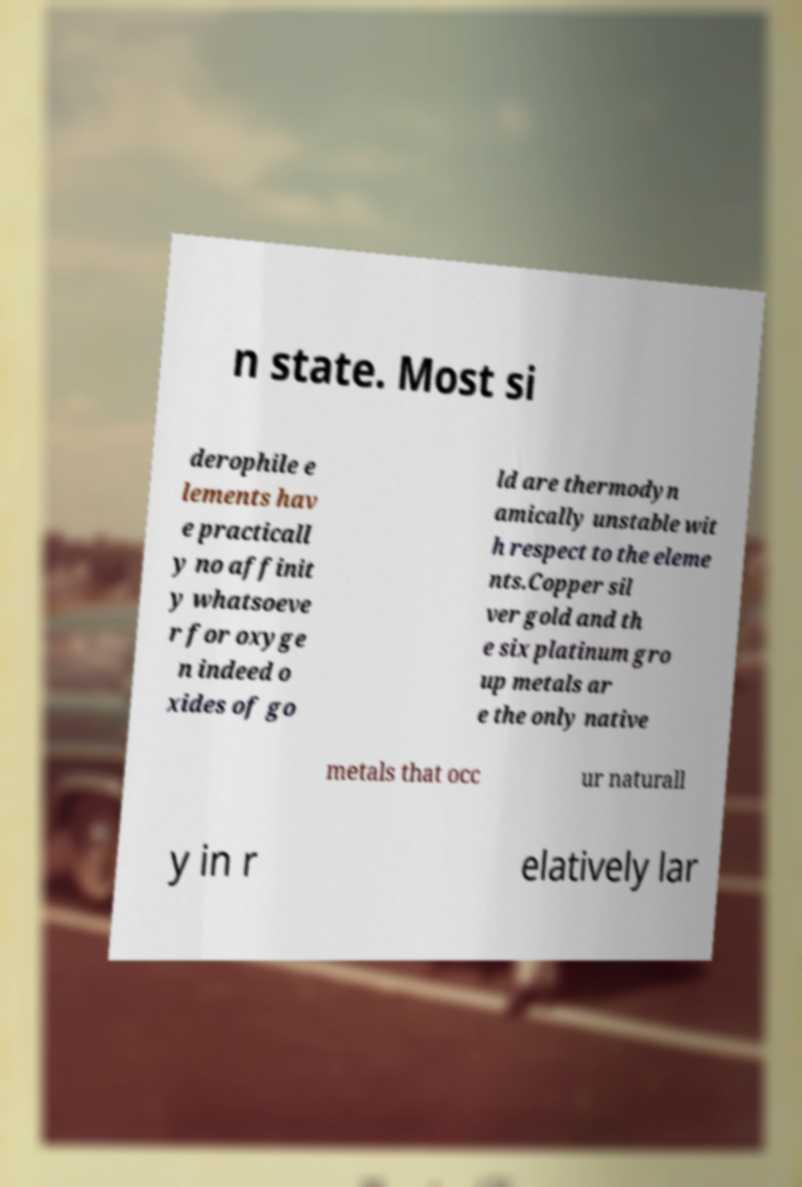There's text embedded in this image that I need extracted. Can you transcribe it verbatim? n state. Most si derophile e lements hav e practicall y no affinit y whatsoeve r for oxyge n indeed o xides of go ld are thermodyn amically unstable wit h respect to the eleme nts.Copper sil ver gold and th e six platinum gro up metals ar e the only native metals that occ ur naturall y in r elatively lar 